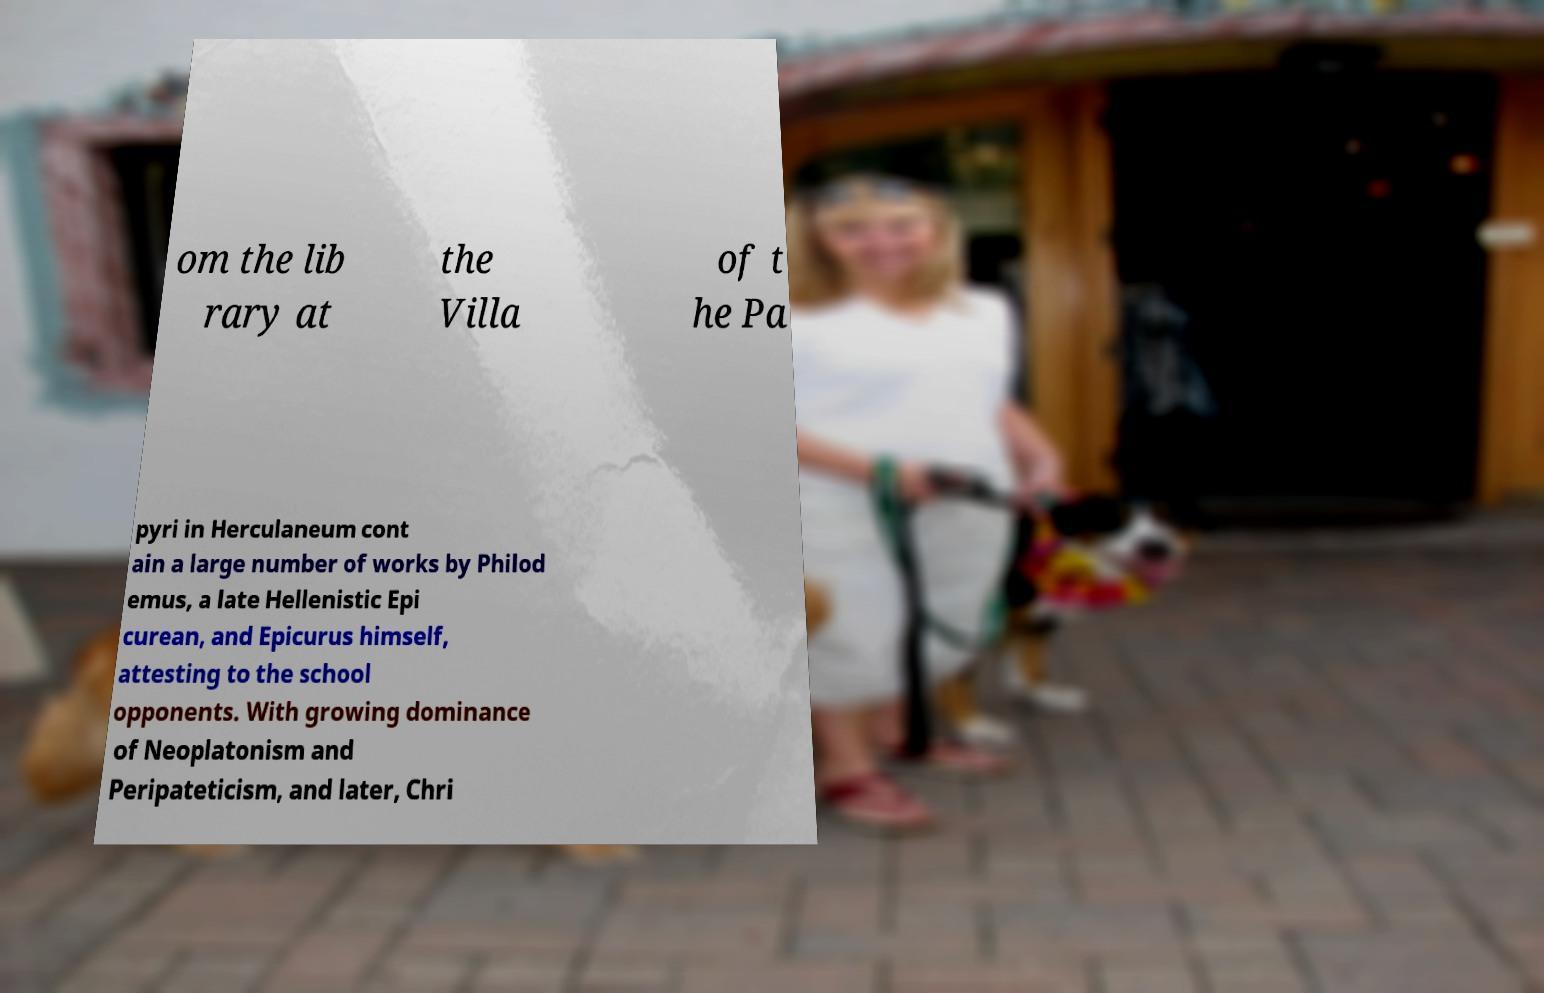Can you read and provide the text displayed in the image?This photo seems to have some interesting text. Can you extract and type it out for me? om the lib rary at the Villa of t he Pa pyri in Herculaneum cont ain a large number of works by Philod emus, a late Hellenistic Epi curean, and Epicurus himself, attesting to the school opponents. With growing dominance of Neoplatonism and Peripateticism, and later, Chri 